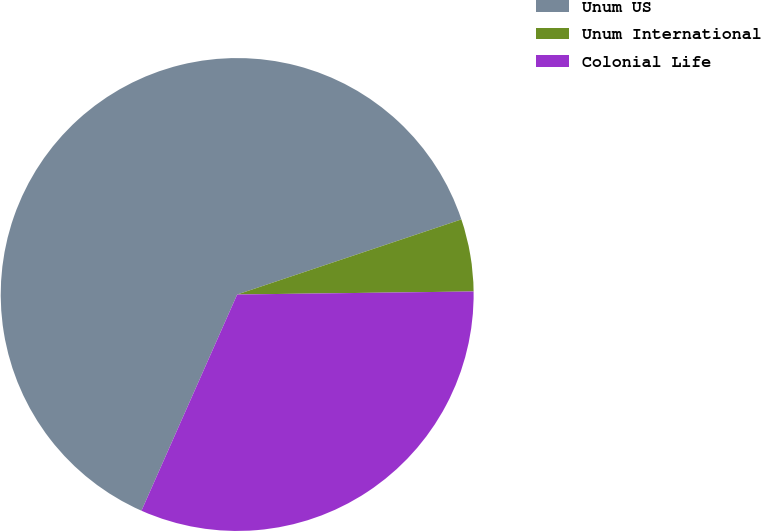<chart> <loc_0><loc_0><loc_500><loc_500><pie_chart><fcel>Unum US<fcel>Unum International<fcel>Colonial Life<nl><fcel>63.23%<fcel>4.94%<fcel>31.84%<nl></chart> 